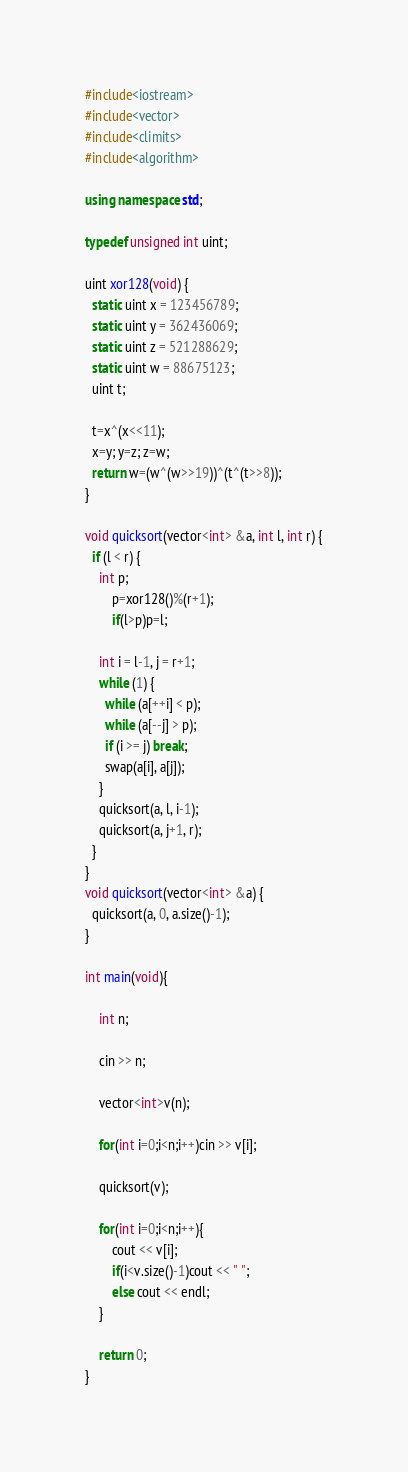Convert code to text. <code><loc_0><loc_0><loc_500><loc_500><_C++_>#include<iostream>
#include<vector>
#include<climits>
#include<algorithm>

using namespace std;

typedef unsigned int uint;
 
uint xor128(void) { 
  static uint x = 123456789;
  static uint y = 362436069;
  static uint z = 521288629;
  static uint w = 88675123; 
  uint t;
  
  t=x^(x<<11);
  x=y; y=z; z=w;
  return w=(w^(w>>19))^(t^(t>>8)); 
}

void quicksort(vector<int> &a, int l, int r) {
  if (l < r) {
  	int p;
  		p=xor128()%(r+1);
  		if(l>p)p=l;
  	
    int i = l-1, j = r+1;
    while (1) {
      while (a[++i] < p);
      while (a[--j] > p);
      if (i >= j) break;
      swap(a[i], a[j]);
    }
    quicksort(a, l, i-1);
    quicksort(a, j+1, r);
  }
}
void quicksort(vector<int> &a) {
  quicksort(a, 0, a.size()-1);
}

int main(void){
	
	int n;
	
	cin >> n;
	
	vector<int>v(n);
	
	for(int i=0;i<n;i++)cin >> v[i];
	
	quicksort(v);

	for(int i=0;i<n;i++){
		cout << v[i];
		if(i<v.size()-1)cout << " ";
		else cout << endl;
	}
	
	return 0;
}</code> 